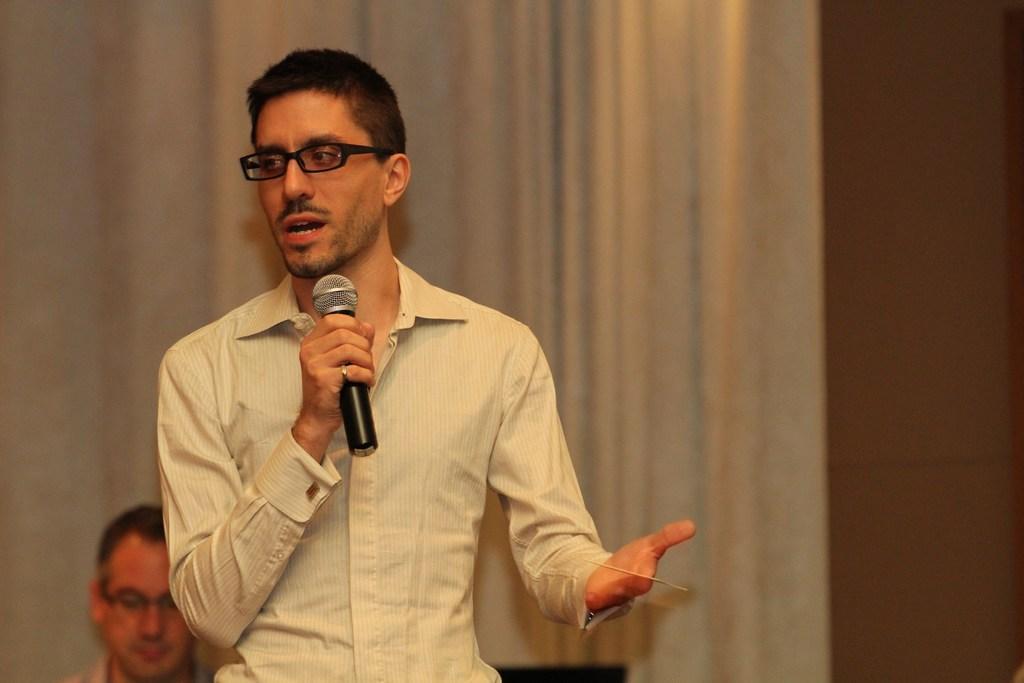In one or two sentences, can you explain what this image depicts? In this image we can see a man standing holding a mic. On the backside we can see a man, curtain and a wall. 